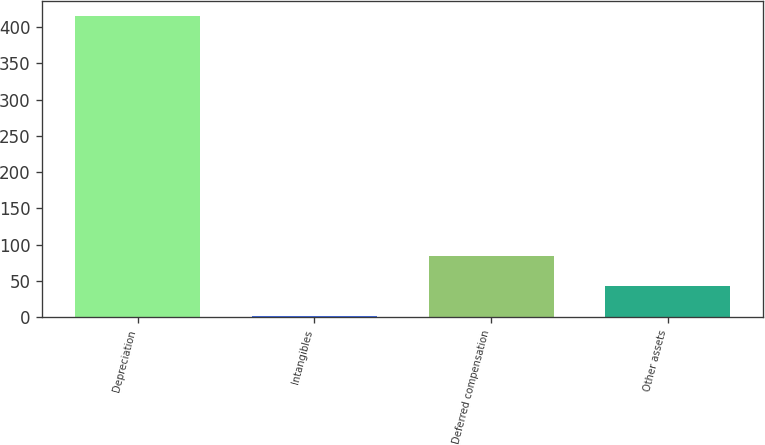Convert chart to OTSL. <chart><loc_0><loc_0><loc_500><loc_500><bar_chart><fcel>Depreciation<fcel>Intangibles<fcel>Deferred compensation<fcel>Other assets<nl><fcel>416<fcel>1<fcel>84<fcel>42.5<nl></chart> 